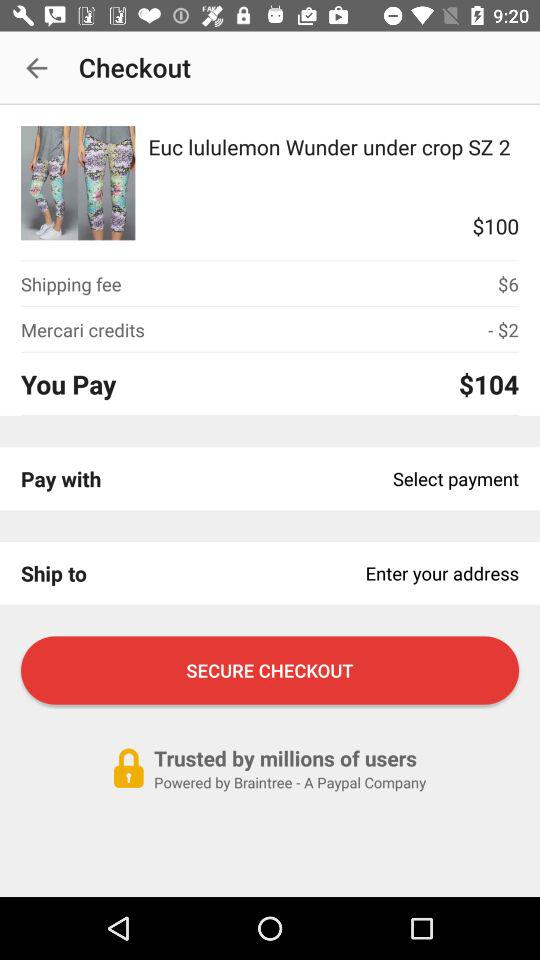How much is the shipping fee?
Answer the question using a single word or phrase. $6 